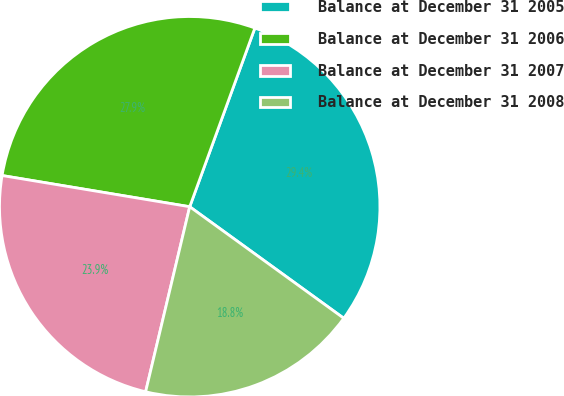Convert chart. <chart><loc_0><loc_0><loc_500><loc_500><pie_chart><fcel>Balance at December 31 2005<fcel>Balance at December 31 2006<fcel>Balance at December 31 2007<fcel>Balance at December 31 2008<nl><fcel>29.41%<fcel>27.94%<fcel>23.9%<fcel>18.75%<nl></chart> 